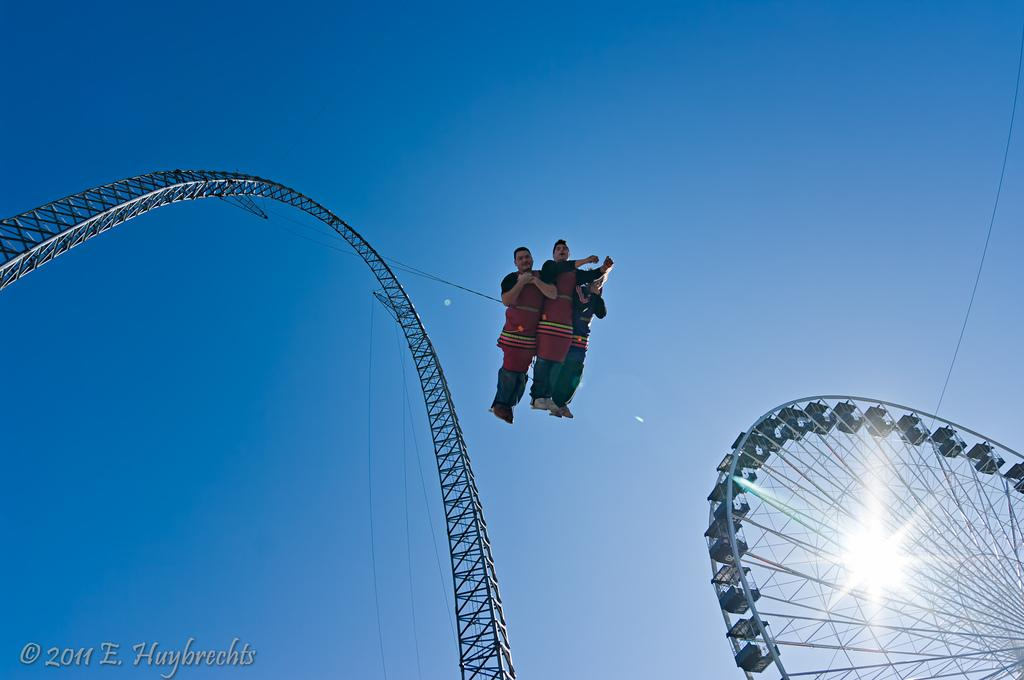How many people are in the image? There are three friends in the image. What are the friends doing in the image? The friends are hanging from a roller coaster. What other attraction can be seen in the image? There is a giant wheel in the image. What is visible at the top of the image? The sky is visible at the top of the image. Can you see a snail crawling on the roller coaster in the image? There is no snail present in the image; it only features the three friends hanging from the roller coaster and the giant wheel. Is the image set in a location with quicksand? There is no indication of quicksand in the image, as it primarily focuses on the friends and the attractions at an amusement park. 